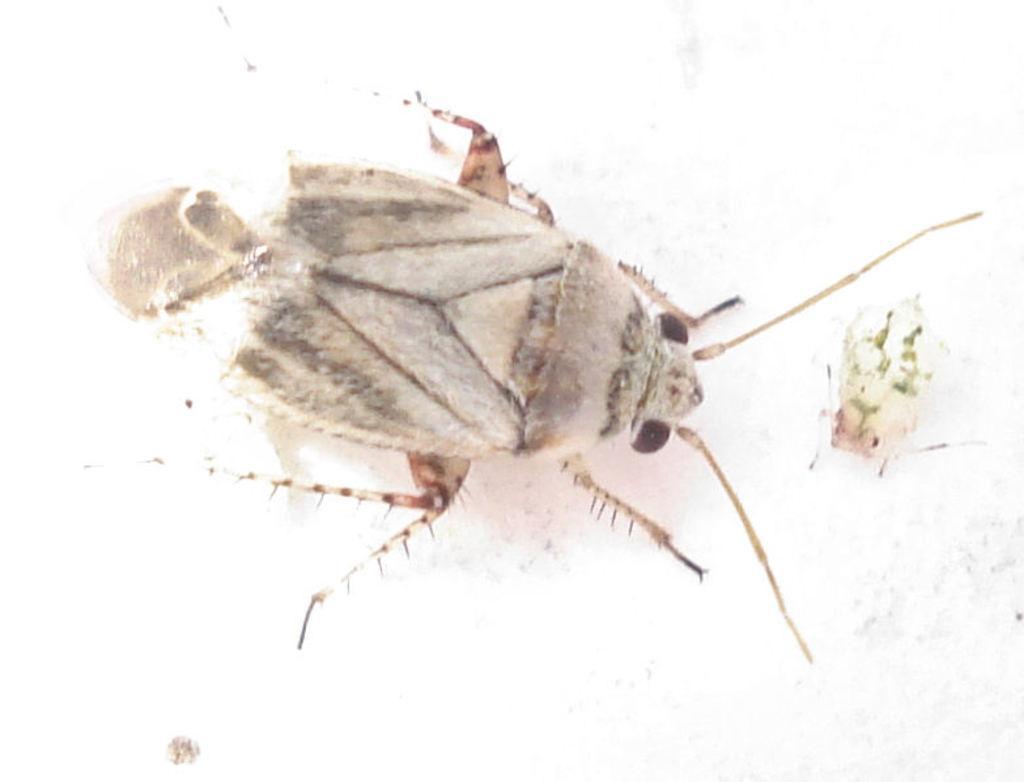Describe this image in one or two sentences. In the image there is an insect. 